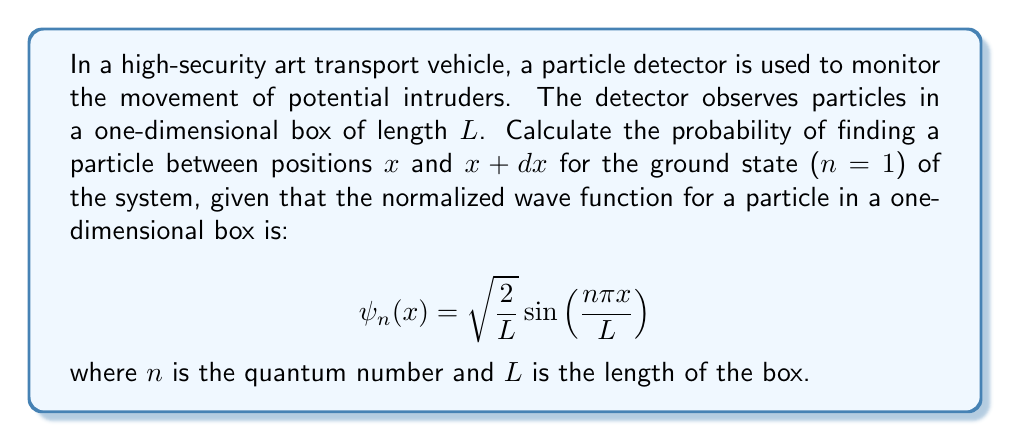Can you solve this math problem? To solve this problem, we'll follow these steps:

1) The probability density function is given by the square of the wave function's absolute value:
   $$P(x) = |\psi(x)|^2$$

2) For the ground state (n=1), the wave function is:
   $$\psi_1(x) = \sqrt{\frac{2}{L}} \sin\left(\frac{\pi x}{L}\right)$$

3) Calculate the probability density:
   $$P(x) = |\psi_1(x)|^2 = \frac{2}{L} \sin^2\left(\frac{\pi x}{L}\right)$$

4) The probability of finding the particle between $x$ and $x + dx$ is:
   $$P(x)dx = \frac{2}{L} \sin^2\left(\frac{\pi x}{L}\right)dx$$

5) This expression represents the probability distribution of particle positions in the confined space of the transport vehicle.

6) To verify, we can integrate this probability over the entire length to ensure it equals 1:

   $$\int_0^L P(x)dx = \int_0^L \frac{2}{L} \sin^2\left(\frac{\pi x}{L}\right)dx = 1$$

   This confirms that our probability distribution is correctly normalized.
Answer: $P(x)dx = \frac{2}{L} \sin^2\left(\frac{\pi x}{L}\right)dx$ 